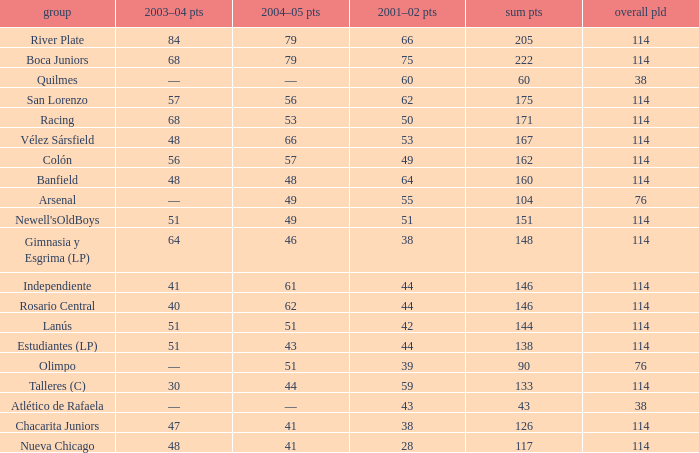Which Team has a Total Pld smaller than 114, and a 2004–05 Pts of 49? Arsenal. 